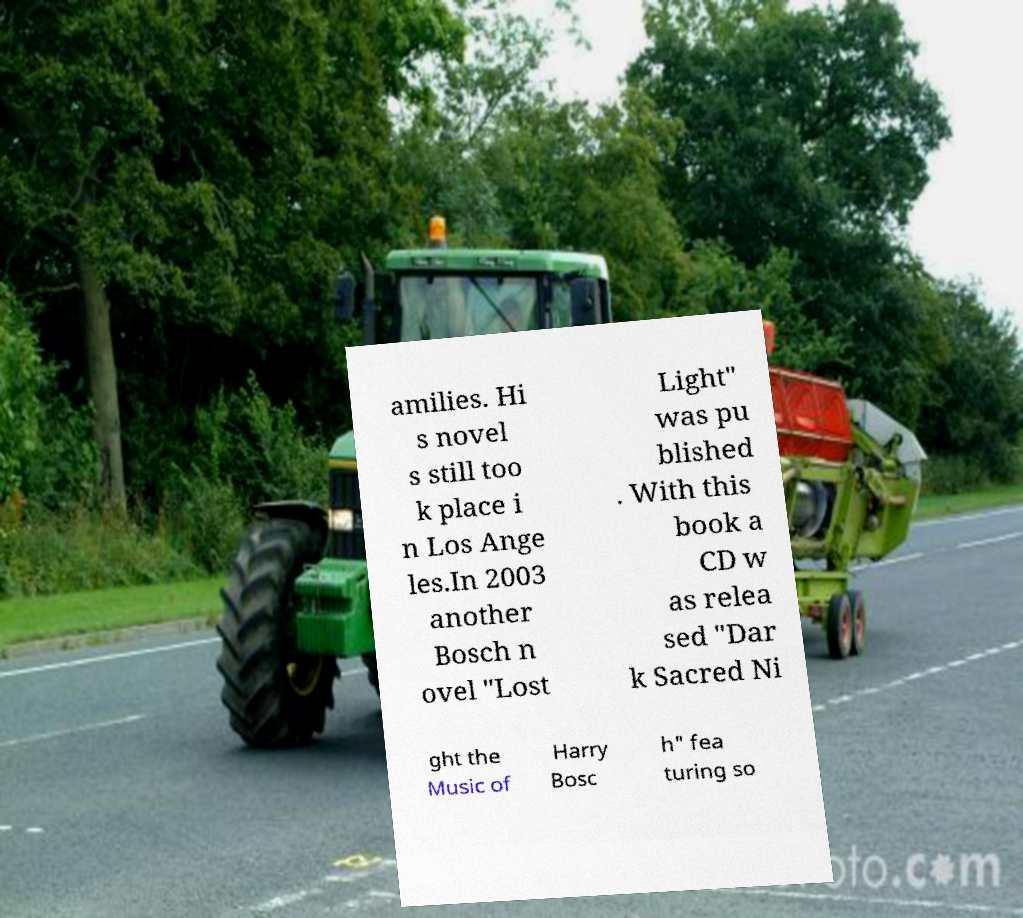I need the written content from this picture converted into text. Can you do that? amilies. Hi s novel s still too k place i n Los Ange les.In 2003 another Bosch n ovel "Lost Light" was pu blished . With this book a CD w as relea sed "Dar k Sacred Ni ght the Music of Harry Bosc h" fea turing so 